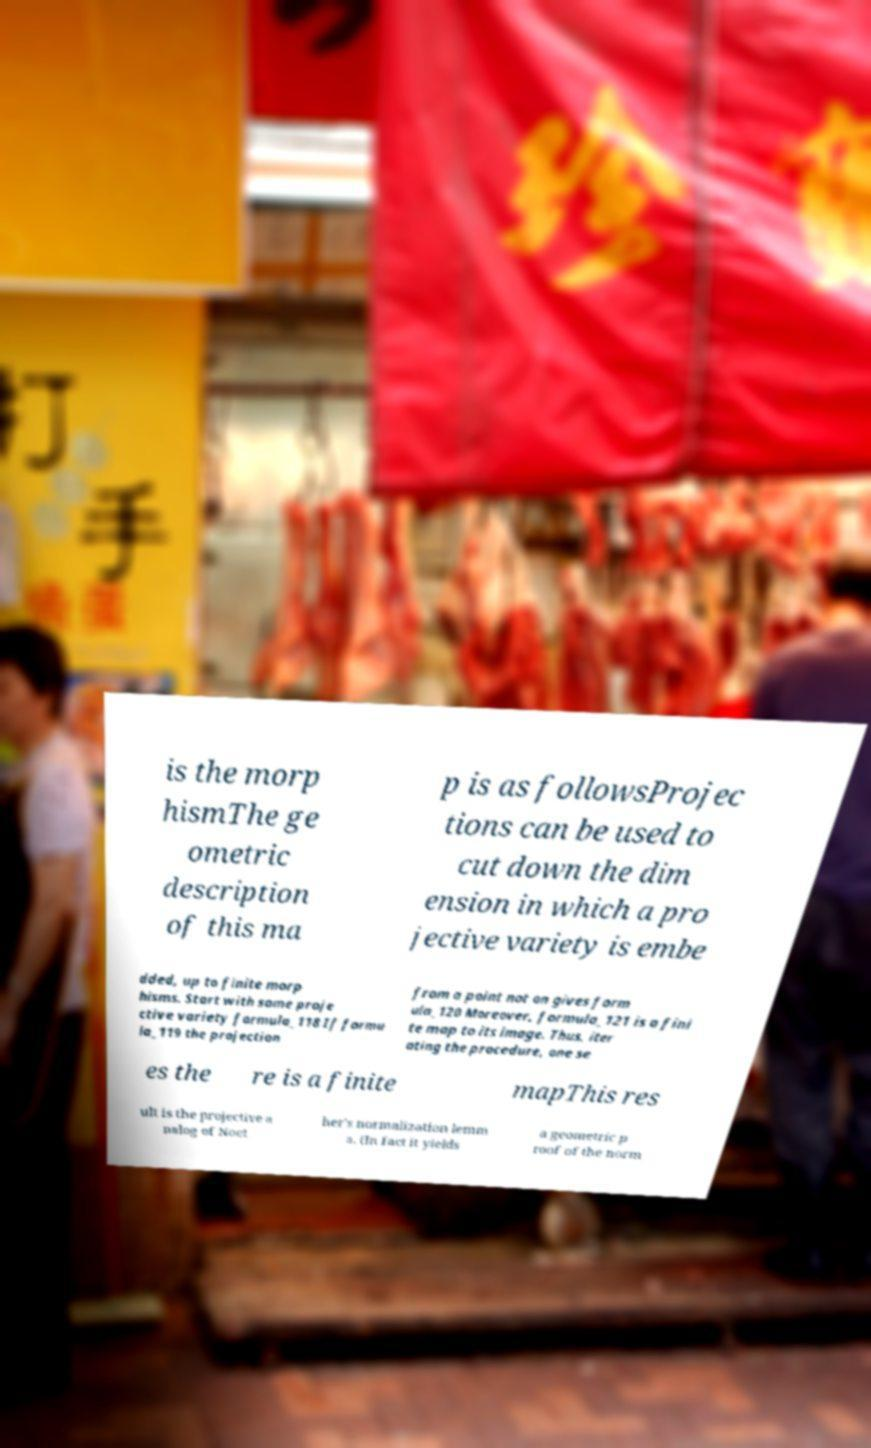Could you assist in decoding the text presented in this image and type it out clearly? is the morp hismThe ge ometric description of this ma p is as followsProjec tions can be used to cut down the dim ension in which a pro jective variety is embe dded, up to finite morp hisms. Start with some proje ctive variety formula_118 If formu la_119 the projection from a point not on gives form ula_120 Moreover, formula_121 is a fini te map to its image. Thus, iter ating the procedure, one se es the re is a finite mapThis res ult is the projective a nalog of Noet her's normalization lemm a. (In fact it yields a geometric p roof of the norm 